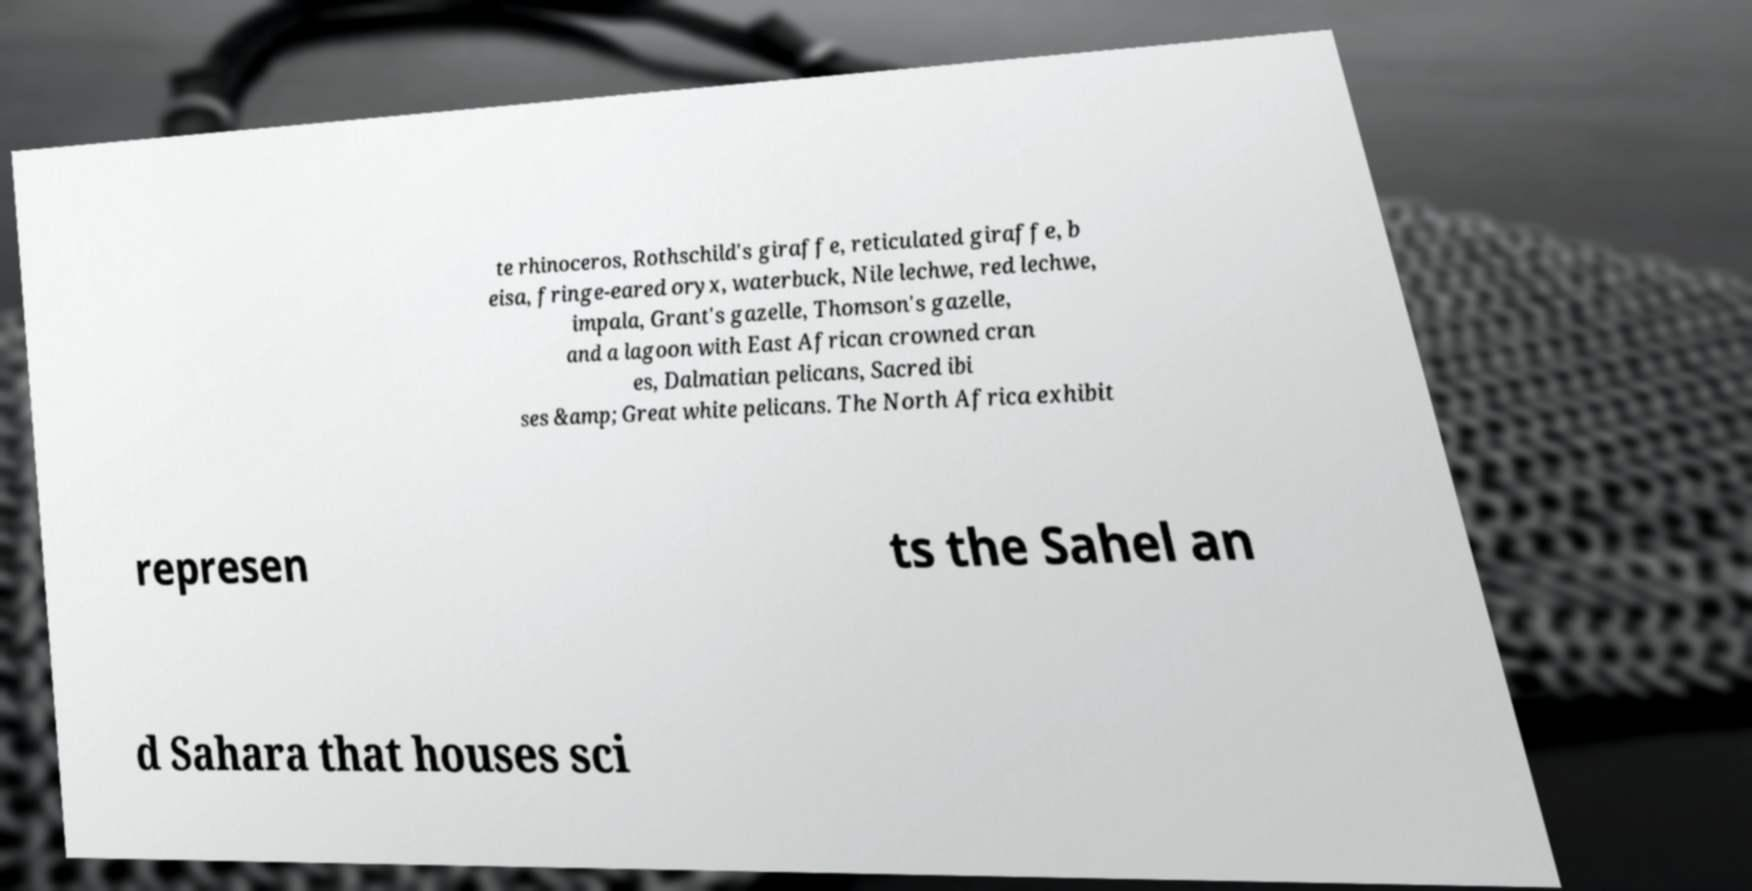Can you read and provide the text displayed in the image?This photo seems to have some interesting text. Can you extract and type it out for me? te rhinoceros, Rothschild's giraffe, reticulated giraffe, b eisa, fringe-eared oryx, waterbuck, Nile lechwe, red lechwe, impala, Grant's gazelle, Thomson's gazelle, and a lagoon with East African crowned cran es, Dalmatian pelicans, Sacred ibi ses &amp; Great white pelicans. The North Africa exhibit represen ts the Sahel an d Sahara that houses sci 